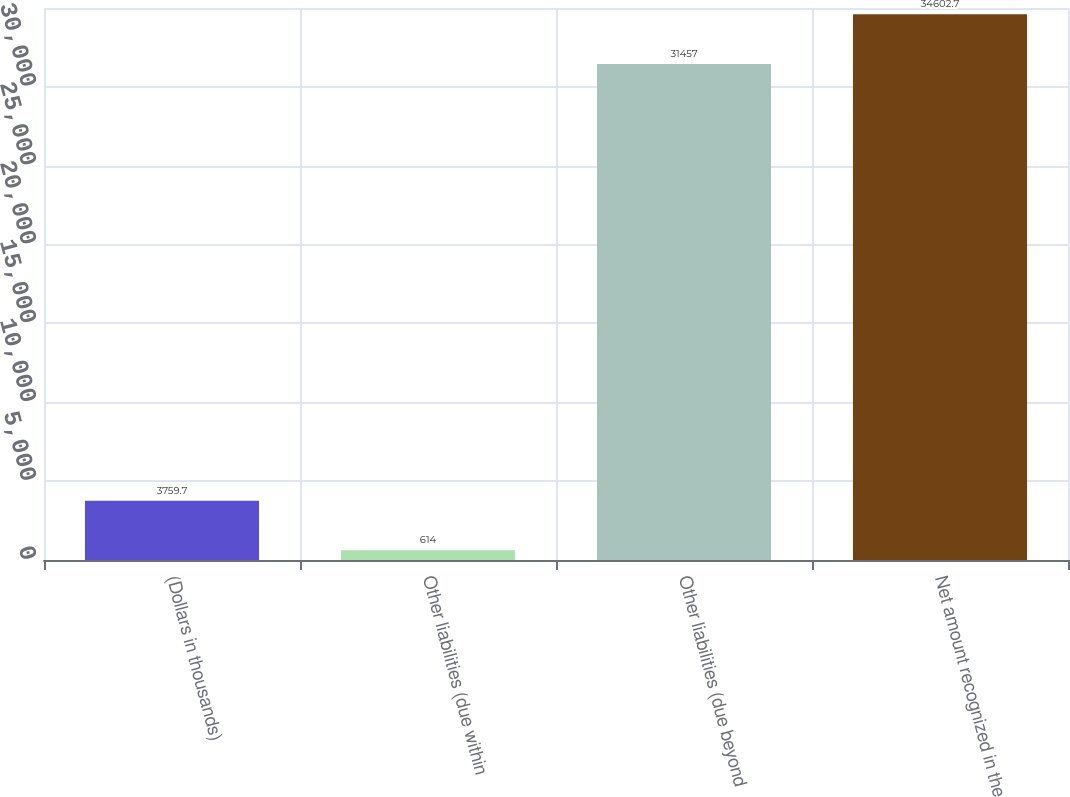<chart> <loc_0><loc_0><loc_500><loc_500><bar_chart><fcel>(Dollars in thousands)<fcel>Other liabilities (due within<fcel>Other liabilities (due beyond<fcel>Net amount recognized in the<nl><fcel>3759.7<fcel>614<fcel>31457<fcel>34602.7<nl></chart> 